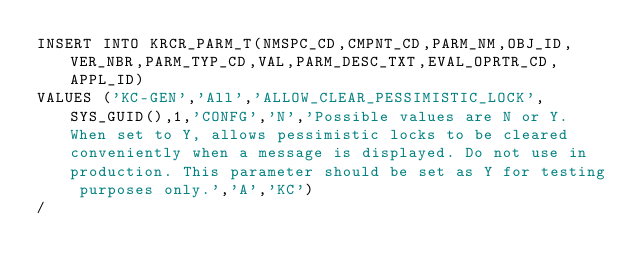Convert code to text. <code><loc_0><loc_0><loc_500><loc_500><_SQL_>INSERT INTO KRCR_PARM_T(NMSPC_CD,CMPNT_CD,PARM_NM,OBJ_ID,VER_NBR,PARM_TYP_CD,VAL,PARM_DESC_TXT,EVAL_OPRTR_CD,APPL_ID)
VALUES ('KC-GEN','All','ALLOW_CLEAR_PESSIMISTIC_LOCK',SYS_GUID(),1,'CONFG','N','Possible values are N or Y. When set to Y, allows pessimistic locks to be cleared conveniently when a message is displayed. Do not use in production. This parameter should be set as Y for testing purposes only.','A','KC')
/
</code> 